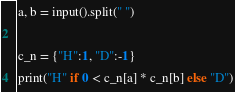Convert code to text. <code><loc_0><loc_0><loc_500><loc_500><_Python_>a, b = input().split(" ")

c_n = {"H":1, "D":-1}
print("H" if 0 < c_n[a] * c_n[b] else "D")</code> 